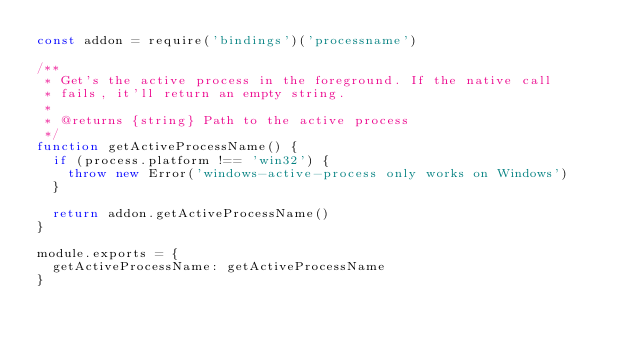Convert code to text. <code><loc_0><loc_0><loc_500><loc_500><_JavaScript_>const addon = require('bindings')('processname')

/**
 * Get's the active process in the foreground. If the native call
 * fails, it'll return an empty string.
 *
 * @returns {string} Path to the active process
 */
function getActiveProcessName() {
  if (process.platform !== 'win32') {
    throw new Error('windows-active-process only works on Windows')
  }

  return addon.getActiveProcessName()
}

module.exports = {
  getActiveProcessName: getActiveProcessName
}
</code> 